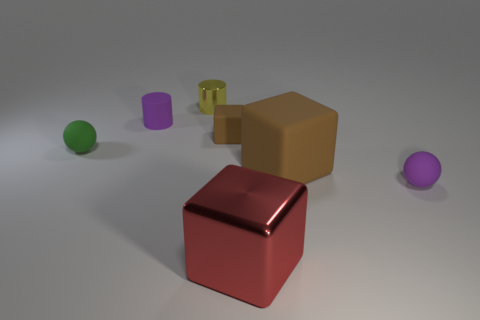Subtract all big cubes. How many cubes are left? 1 Add 2 balls. How many objects exist? 9 Subtract all red blocks. How many blocks are left? 2 Subtract 1 cylinders. How many cylinders are left? 1 Subtract all brown cylinders. Subtract all brown blocks. How many cylinders are left? 2 Subtract all cyan blocks. How many gray balls are left? 0 Subtract all big shiny balls. Subtract all blocks. How many objects are left? 4 Add 6 shiny objects. How many shiny objects are left? 8 Add 6 small cubes. How many small cubes exist? 7 Subtract 0 yellow cubes. How many objects are left? 7 